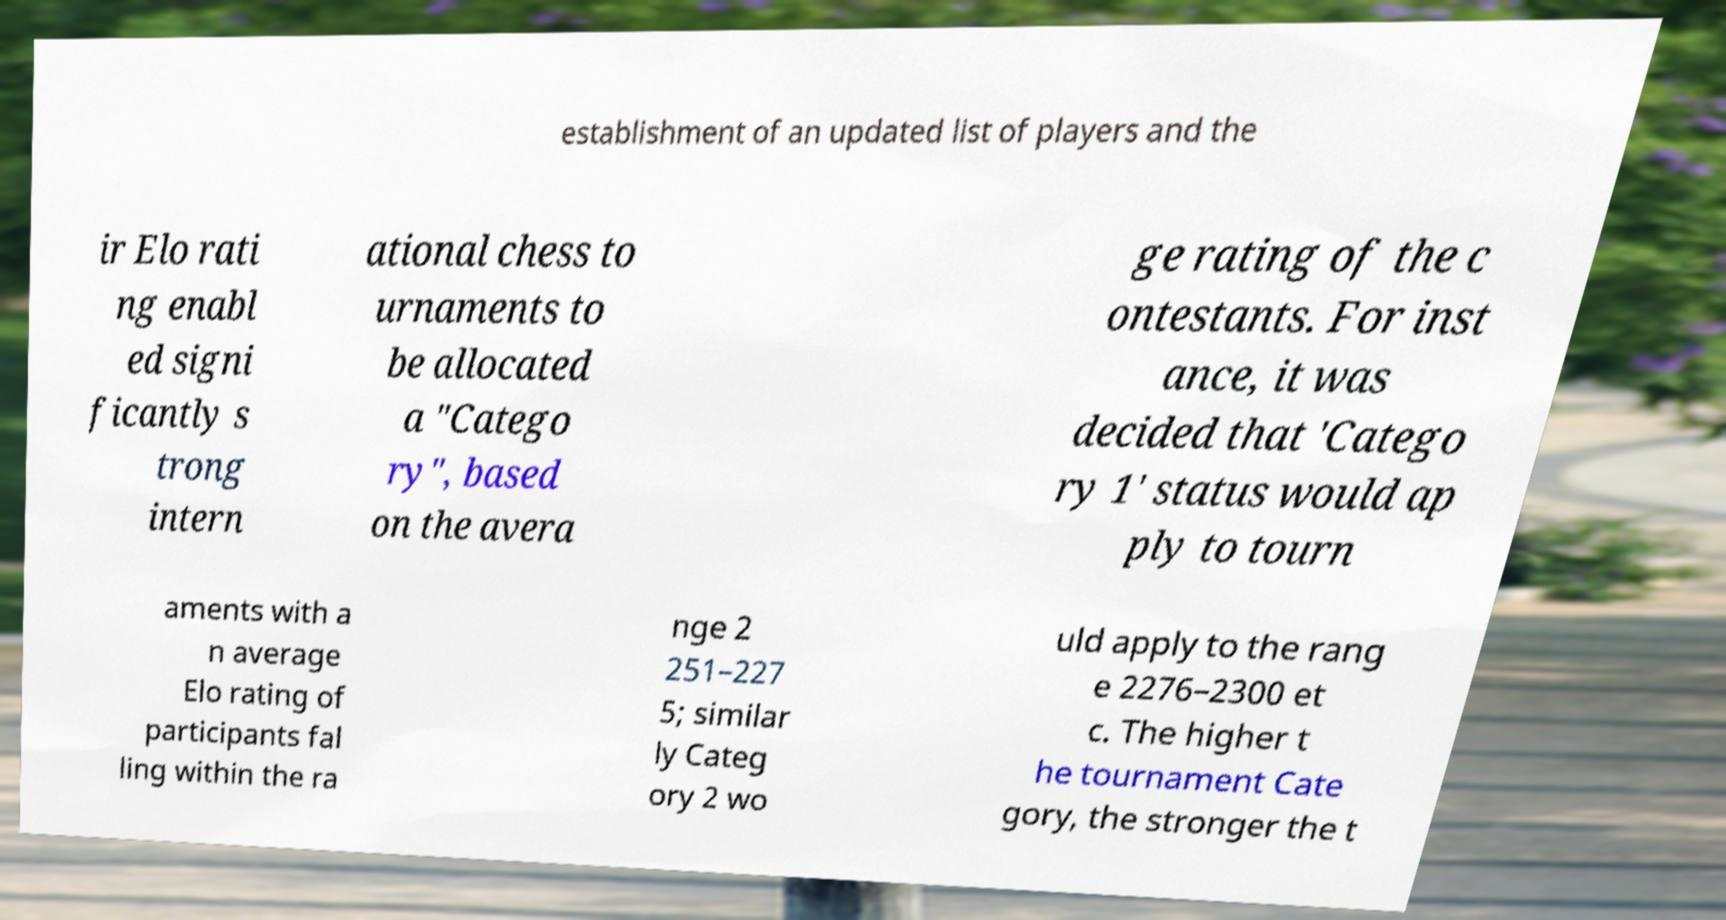For documentation purposes, I need the text within this image transcribed. Could you provide that? establishment of an updated list of players and the ir Elo rati ng enabl ed signi ficantly s trong intern ational chess to urnaments to be allocated a "Catego ry", based on the avera ge rating of the c ontestants. For inst ance, it was decided that 'Catego ry 1' status would ap ply to tourn aments with a n average Elo rating of participants fal ling within the ra nge 2 251–227 5; similar ly Categ ory 2 wo uld apply to the rang e 2276–2300 et c. The higher t he tournament Cate gory, the stronger the t 